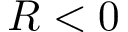Convert formula to latex. <formula><loc_0><loc_0><loc_500><loc_500>R < 0</formula> 